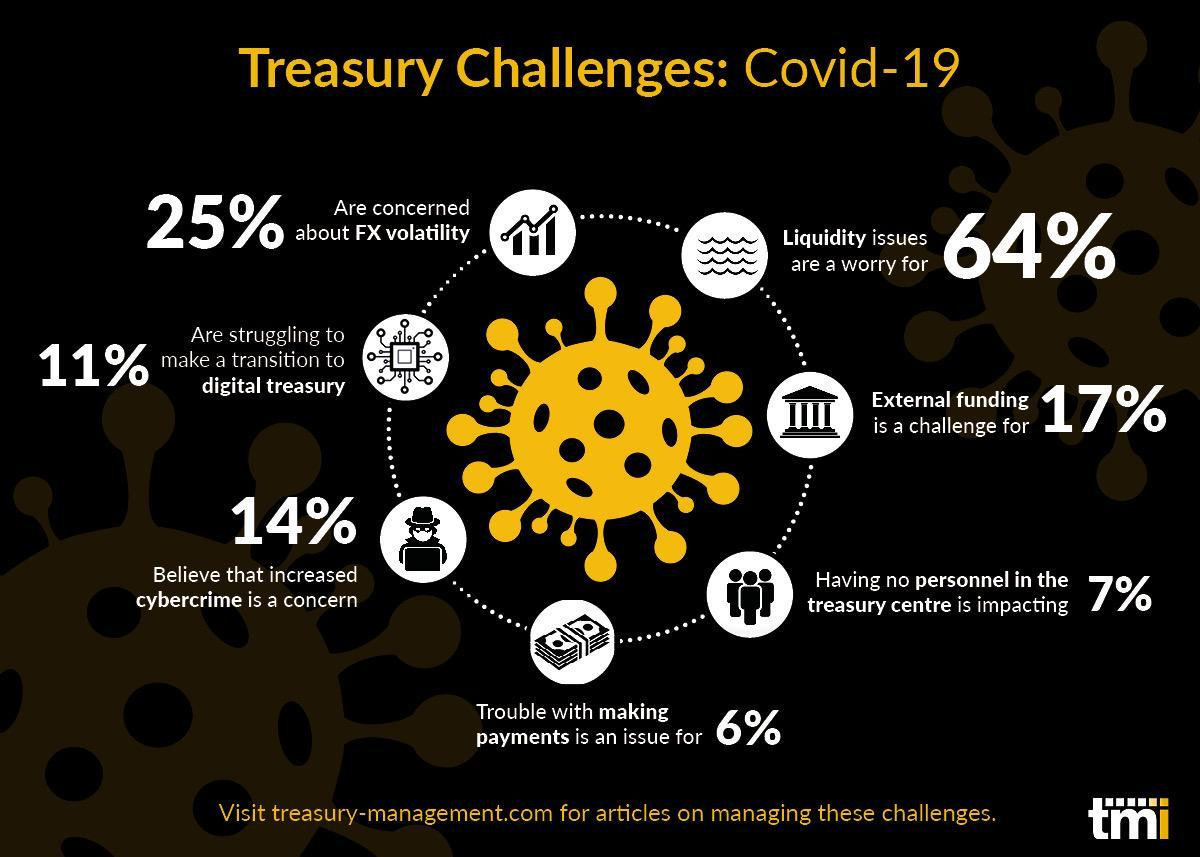Which is the major issue listed under the treasury challenges due to Covid-19?
Answer the question with a short phrase. Liquidity Which is the least issue listed under the treasury challenges due to Covid-19? Making Payments 